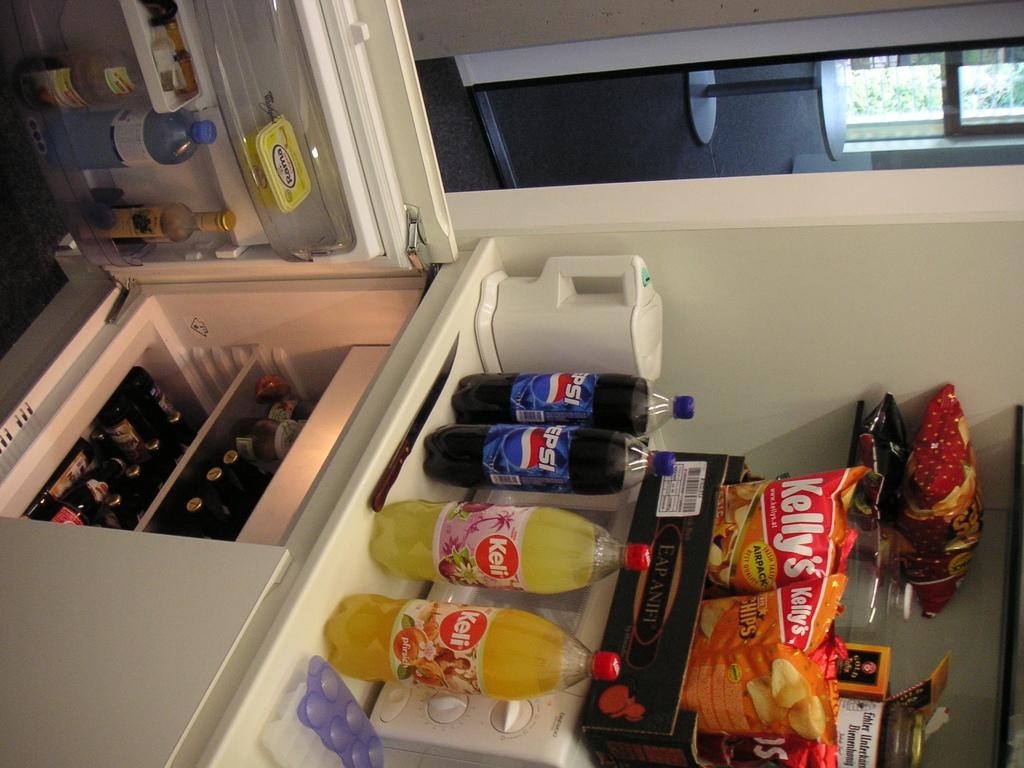<image>
Create a compact narrative representing the image presented. Two bottles of Keli drink sit next to two bottles of Pepsi on top of a fridge. 